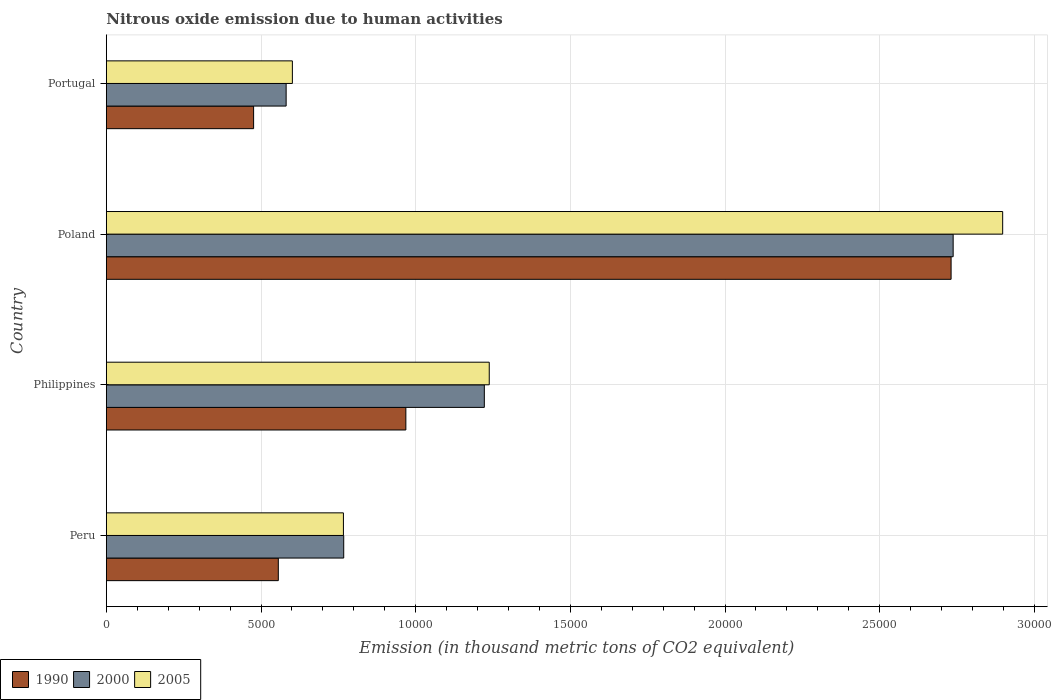Are the number of bars per tick equal to the number of legend labels?
Make the answer very short. Yes. Are the number of bars on each tick of the Y-axis equal?
Your answer should be very brief. Yes. How many bars are there on the 4th tick from the top?
Your response must be concise. 3. How many bars are there on the 4th tick from the bottom?
Keep it short and to the point. 3. In how many cases, is the number of bars for a given country not equal to the number of legend labels?
Ensure brevity in your answer.  0. What is the amount of nitrous oxide emitted in 2005 in Poland?
Give a very brief answer. 2.90e+04. Across all countries, what is the maximum amount of nitrous oxide emitted in 2005?
Your answer should be compact. 2.90e+04. Across all countries, what is the minimum amount of nitrous oxide emitted in 2000?
Offer a terse response. 5812.6. In which country was the amount of nitrous oxide emitted in 2000 minimum?
Give a very brief answer. Portugal. What is the total amount of nitrous oxide emitted in 2000 in the graph?
Provide a short and direct response. 5.31e+04. What is the difference between the amount of nitrous oxide emitted in 2000 in Peru and that in Philippines?
Make the answer very short. -4545.2. What is the difference between the amount of nitrous oxide emitted in 2005 in Peru and the amount of nitrous oxide emitted in 2000 in Portugal?
Give a very brief answer. 1851.6. What is the average amount of nitrous oxide emitted in 2000 per country?
Provide a short and direct response. 1.33e+04. What is the difference between the amount of nitrous oxide emitted in 2005 and amount of nitrous oxide emitted in 2000 in Peru?
Provide a succinct answer. -9.7. What is the ratio of the amount of nitrous oxide emitted in 1990 in Philippines to that in Poland?
Your answer should be compact. 0.35. What is the difference between the highest and the second highest amount of nitrous oxide emitted in 2005?
Provide a succinct answer. 1.66e+04. What is the difference between the highest and the lowest amount of nitrous oxide emitted in 2005?
Keep it short and to the point. 2.30e+04. Is the sum of the amount of nitrous oxide emitted in 2005 in Philippines and Portugal greater than the maximum amount of nitrous oxide emitted in 2000 across all countries?
Your answer should be very brief. No. What does the 1st bar from the bottom in Poland represents?
Give a very brief answer. 1990. How many bars are there?
Offer a very short reply. 12. Are all the bars in the graph horizontal?
Provide a short and direct response. Yes. How many countries are there in the graph?
Give a very brief answer. 4. What is the difference between two consecutive major ticks on the X-axis?
Provide a short and direct response. 5000. Does the graph contain any zero values?
Offer a very short reply. No. How many legend labels are there?
Offer a terse response. 3. What is the title of the graph?
Your answer should be compact. Nitrous oxide emission due to human activities. Does "1982" appear as one of the legend labels in the graph?
Provide a succinct answer. No. What is the label or title of the X-axis?
Keep it short and to the point. Emission (in thousand metric tons of CO2 equivalent). What is the label or title of the Y-axis?
Provide a succinct answer. Country. What is the Emission (in thousand metric tons of CO2 equivalent) of 1990 in Peru?
Make the answer very short. 5559.3. What is the Emission (in thousand metric tons of CO2 equivalent) of 2000 in Peru?
Offer a very short reply. 7673.9. What is the Emission (in thousand metric tons of CO2 equivalent) of 2005 in Peru?
Offer a very short reply. 7664.2. What is the Emission (in thousand metric tons of CO2 equivalent) in 1990 in Philippines?
Give a very brief answer. 9682.8. What is the Emission (in thousand metric tons of CO2 equivalent) of 2000 in Philippines?
Provide a succinct answer. 1.22e+04. What is the Emission (in thousand metric tons of CO2 equivalent) of 2005 in Philippines?
Provide a succinct answer. 1.24e+04. What is the Emission (in thousand metric tons of CO2 equivalent) in 1990 in Poland?
Provide a short and direct response. 2.73e+04. What is the Emission (in thousand metric tons of CO2 equivalent) in 2000 in Poland?
Provide a succinct answer. 2.74e+04. What is the Emission (in thousand metric tons of CO2 equivalent) of 2005 in Poland?
Offer a terse response. 2.90e+04. What is the Emission (in thousand metric tons of CO2 equivalent) of 1990 in Portugal?
Make the answer very short. 4760.8. What is the Emission (in thousand metric tons of CO2 equivalent) in 2000 in Portugal?
Your response must be concise. 5812.6. What is the Emission (in thousand metric tons of CO2 equivalent) of 2005 in Portugal?
Offer a terse response. 6014.2. Across all countries, what is the maximum Emission (in thousand metric tons of CO2 equivalent) of 1990?
Your answer should be compact. 2.73e+04. Across all countries, what is the maximum Emission (in thousand metric tons of CO2 equivalent) in 2000?
Keep it short and to the point. 2.74e+04. Across all countries, what is the maximum Emission (in thousand metric tons of CO2 equivalent) in 2005?
Your answer should be very brief. 2.90e+04. Across all countries, what is the minimum Emission (in thousand metric tons of CO2 equivalent) in 1990?
Make the answer very short. 4760.8. Across all countries, what is the minimum Emission (in thousand metric tons of CO2 equivalent) of 2000?
Your response must be concise. 5812.6. Across all countries, what is the minimum Emission (in thousand metric tons of CO2 equivalent) in 2005?
Offer a very short reply. 6014.2. What is the total Emission (in thousand metric tons of CO2 equivalent) in 1990 in the graph?
Keep it short and to the point. 4.73e+04. What is the total Emission (in thousand metric tons of CO2 equivalent) of 2000 in the graph?
Your answer should be compact. 5.31e+04. What is the total Emission (in thousand metric tons of CO2 equivalent) of 2005 in the graph?
Your answer should be compact. 5.50e+04. What is the difference between the Emission (in thousand metric tons of CO2 equivalent) in 1990 in Peru and that in Philippines?
Your answer should be very brief. -4123.5. What is the difference between the Emission (in thousand metric tons of CO2 equivalent) of 2000 in Peru and that in Philippines?
Make the answer very short. -4545.2. What is the difference between the Emission (in thousand metric tons of CO2 equivalent) of 2005 in Peru and that in Philippines?
Provide a short and direct response. -4713.9. What is the difference between the Emission (in thousand metric tons of CO2 equivalent) of 1990 in Peru and that in Poland?
Keep it short and to the point. -2.17e+04. What is the difference between the Emission (in thousand metric tons of CO2 equivalent) in 2000 in Peru and that in Poland?
Offer a terse response. -1.97e+04. What is the difference between the Emission (in thousand metric tons of CO2 equivalent) of 2005 in Peru and that in Poland?
Keep it short and to the point. -2.13e+04. What is the difference between the Emission (in thousand metric tons of CO2 equivalent) in 1990 in Peru and that in Portugal?
Provide a succinct answer. 798.5. What is the difference between the Emission (in thousand metric tons of CO2 equivalent) of 2000 in Peru and that in Portugal?
Offer a very short reply. 1861.3. What is the difference between the Emission (in thousand metric tons of CO2 equivalent) of 2005 in Peru and that in Portugal?
Your answer should be compact. 1650. What is the difference between the Emission (in thousand metric tons of CO2 equivalent) in 1990 in Philippines and that in Poland?
Provide a short and direct response. -1.76e+04. What is the difference between the Emission (in thousand metric tons of CO2 equivalent) in 2000 in Philippines and that in Poland?
Your answer should be compact. -1.52e+04. What is the difference between the Emission (in thousand metric tons of CO2 equivalent) in 2005 in Philippines and that in Poland?
Provide a short and direct response. -1.66e+04. What is the difference between the Emission (in thousand metric tons of CO2 equivalent) of 1990 in Philippines and that in Portugal?
Offer a terse response. 4922. What is the difference between the Emission (in thousand metric tons of CO2 equivalent) of 2000 in Philippines and that in Portugal?
Offer a very short reply. 6406.5. What is the difference between the Emission (in thousand metric tons of CO2 equivalent) of 2005 in Philippines and that in Portugal?
Offer a terse response. 6363.9. What is the difference between the Emission (in thousand metric tons of CO2 equivalent) in 1990 in Poland and that in Portugal?
Your answer should be compact. 2.25e+04. What is the difference between the Emission (in thousand metric tons of CO2 equivalent) in 2000 in Poland and that in Portugal?
Provide a short and direct response. 2.16e+04. What is the difference between the Emission (in thousand metric tons of CO2 equivalent) of 2005 in Poland and that in Portugal?
Ensure brevity in your answer.  2.30e+04. What is the difference between the Emission (in thousand metric tons of CO2 equivalent) of 1990 in Peru and the Emission (in thousand metric tons of CO2 equivalent) of 2000 in Philippines?
Ensure brevity in your answer.  -6659.8. What is the difference between the Emission (in thousand metric tons of CO2 equivalent) of 1990 in Peru and the Emission (in thousand metric tons of CO2 equivalent) of 2005 in Philippines?
Provide a short and direct response. -6818.8. What is the difference between the Emission (in thousand metric tons of CO2 equivalent) of 2000 in Peru and the Emission (in thousand metric tons of CO2 equivalent) of 2005 in Philippines?
Offer a very short reply. -4704.2. What is the difference between the Emission (in thousand metric tons of CO2 equivalent) of 1990 in Peru and the Emission (in thousand metric tons of CO2 equivalent) of 2000 in Poland?
Provide a succinct answer. -2.18e+04. What is the difference between the Emission (in thousand metric tons of CO2 equivalent) of 1990 in Peru and the Emission (in thousand metric tons of CO2 equivalent) of 2005 in Poland?
Keep it short and to the point. -2.34e+04. What is the difference between the Emission (in thousand metric tons of CO2 equivalent) of 2000 in Peru and the Emission (in thousand metric tons of CO2 equivalent) of 2005 in Poland?
Ensure brevity in your answer.  -2.13e+04. What is the difference between the Emission (in thousand metric tons of CO2 equivalent) of 1990 in Peru and the Emission (in thousand metric tons of CO2 equivalent) of 2000 in Portugal?
Make the answer very short. -253.3. What is the difference between the Emission (in thousand metric tons of CO2 equivalent) of 1990 in Peru and the Emission (in thousand metric tons of CO2 equivalent) of 2005 in Portugal?
Your answer should be compact. -454.9. What is the difference between the Emission (in thousand metric tons of CO2 equivalent) in 2000 in Peru and the Emission (in thousand metric tons of CO2 equivalent) in 2005 in Portugal?
Offer a terse response. 1659.7. What is the difference between the Emission (in thousand metric tons of CO2 equivalent) of 1990 in Philippines and the Emission (in thousand metric tons of CO2 equivalent) of 2000 in Poland?
Give a very brief answer. -1.77e+04. What is the difference between the Emission (in thousand metric tons of CO2 equivalent) of 1990 in Philippines and the Emission (in thousand metric tons of CO2 equivalent) of 2005 in Poland?
Offer a very short reply. -1.93e+04. What is the difference between the Emission (in thousand metric tons of CO2 equivalent) of 2000 in Philippines and the Emission (in thousand metric tons of CO2 equivalent) of 2005 in Poland?
Ensure brevity in your answer.  -1.68e+04. What is the difference between the Emission (in thousand metric tons of CO2 equivalent) of 1990 in Philippines and the Emission (in thousand metric tons of CO2 equivalent) of 2000 in Portugal?
Keep it short and to the point. 3870.2. What is the difference between the Emission (in thousand metric tons of CO2 equivalent) in 1990 in Philippines and the Emission (in thousand metric tons of CO2 equivalent) in 2005 in Portugal?
Your answer should be very brief. 3668.6. What is the difference between the Emission (in thousand metric tons of CO2 equivalent) in 2000 in Philippines and the Emission (in thousand metric tons of CO2 equivalent) in 2005 in Portugal?
Offer a terse response. 6204.9. What is the difference between the Emission (in thousand metric tons of CO2 equivalent) in 1990 in Poland and the Emission (in thousand metric tons of CO2 equivalent) in 2000 in Portugal?
Your answer should be very brief. 2.15e+04. What is the difference between the Emission (in thousand metric tons of CO2 equivalent) in 1990 in Poland and the Emission (in thousand metric tons of CO2 equivalent) in 2005 in Portugal?
Provide a succinct answer. 2.13e+04. What is the difference between the Emission (in thousand metric tons of CO2 equivalent) in 2000 in Poland and the Emission (in thousand metric tons of CO2 equivalent) in 2005 in Portugal?
Your answer should be compact. 2.14e+04. What is the average Emission (in thousand metric tons of CO2 equivalent) of 1990 per country?
Your answer should be very brief. 1.18e+04. What is the average Emission (in thousand metric tons of CO2 equivalent) of 2000 per country?
Ensure brevity in your answer.  1.33e+04. What is the average Emission (in thousand metric tons of CO2 equivalent) of 2005 per country?
Keep it short and to the point. 1.38e+04. What is the difference between the Emission (in thousand metric tons of CO2 equivalent) in 1990 and Emission (in thousand metric tons of CO2 equivalent) in 2000 in Peru?
Offer a very short reply. -2114.6. What is the difference between the Emission (in thousand metric tons of CO2 equivalent) in 1990 and Emission (in thousand metric tons of CO2 equivalent) in 2005 in Peru?
Offer a very short reply. -2104.9. What is the difference between the Emission (in thousand metric tons of CO2 equivalent) in 1990 and Emission (in thousand metric tons of CO2 equivalent) in 2000 in Philippines?
Keep it short and to the point. -2536.3. What is the difference between the Emission (in thousand metric tons of CO2 equivalent) of 1990 and Emission (in thousand metric tons of CO2 equivalent) of 2005 in Philippines?
Provide a succinct answer. -2695.3. What is the difference between the Emission (in thousand metric tons of CO2 equivalent) in 2000 and Emission (in thousand metric tons of CO2 equivalent) in 2005 in Philippines?
Ensure brevity in your answer.  -159. What is the difference between the Emission (in thousand metric tons of CO2 equivalent) of 1990 and Emission (in thousand metric tons of CO2 equivalent) of 2000 in Poland?
Your response must be concise. -66.8. What is the difference between the Emission (in thousand metric tons of CO2 equivalent) in 1990 and Emission (in thousand metric tons of CO2 equivalent) in 2005 in Poland?
Ensure brevity in your answer.  -1667.4. What is the difference between the Emission (in thousand metric tons of CO2 equivalent) in 2000 and Emission (in thousand metric tons of CO2 equivalent) in 2005 in Poland?
Give a very brief answer. -1600.6. What is the difference between the Emission (in thousand metric tons of CO2 equivalent) of 1990 and Emission (in thousand metric tons of CO2 equivalent) of 2000 in Portugal?
Ensure brevity in your answer.  -1051.8. What is the difference between the Emission (in thousand metric tons of CO2 equivalent) of 1990 and Emission (in thousand metric tons of CO2 equivalent) of 2005 in Portugal?
Offer a terse response. -1253.4. What is the difference between the Emission (in thousand metric tons of CO2 equivalent) in 2000 and Emission (in thousand metric tons of CO2 equivalent) in 2005 in Portugal?
Make the answer very short. -201.6. What is the ratio of the Emission (in thousand metric tons of CO2 equivalent) of 1990 in Peru to that in Philippines?
Offer a terse response. 0.57. What is the ratio of the Emission (in thousand metric tons of CO2 equivalent) in 2000 in Peru to that in Philippines?
Offer a very short reply. 0.63. What is the ratio of the Emission (in thousand metric tons of CO2 equivalent) of 2005 in Peru to that in Philippines?
Make the answer very short. 0.62. What is the ratio of the Emission (in thousand metric tons of CO2 equivalent) in 1990 in Peru to that in Poland?
Make the answer very short. 0.2. What is the ratio of the Emission (in thousand metric tons of CO2 equivalent) of 2000 in Peru to that in Poland?
Give a very brief answer. 0.28. What is the ratio of the Emission (in thousand metric tons of CO2 equivalent) of 2005 in Peru to that in Poland?
Your answer should be very brief. 0.26. What is the ratio of the Emission (in thousand metric tons of CO2 equivalent) of 1990 in Peru to that in Portugal?
Provide a short and direct response. 1.17. What is the ratio of the Emission (in thousand metric tons of CO2 equivalent) of 2000 in Peru to that in Portugal?
Your response must be concise. 1.32. What is the ratio of the Emission (in thousand metric tons of CO2 equivalent) in 2005 in Peru to that in Portugal?
Your response must be concise. 1.27. What is the ratio of the Emission (in thousand metric tons of CO2 equivalent) of 1990 in Philippines to that in Poland?
Your answer should be compact. 0.35. What is the ratio of the Emission (in thousand metric tons of CO2 equivalent) in 2000 in Philippines to that in Poland?
Keep it short and to the point. 0.45. What is the ratio of the Emission (in thousand metric tons of CO2 equivalent) in 2005 in Philippines to that in Poland?
Your response must be concise. 0.43. What is the ratio of the Emission (in thousand metric tons of CO2 equivalent) in 1990 in Philippines to that in Portugal?
Ensure brevity in your answer.  2.03. What is the ratio of the Emission (in thousand metric tons of CO2 equivalent) of 2000 in Philippines to that in Portugal?
Keep it short and to the point. 2.1. What is the ratio of the Emission (in thousand metric tons of CO2 equivalent) in 2005 in Philippines to that in Portugal?
Your answer should be very brief. 2.06. What is the ratio of the Emission (in thousand metric tons of CO2 equivalent) of 1990 in Poland to that in Portugal?
Offer a very short reply. 5.74. What is the ratio of the Emission (in thousand metric tons of CO2 equivalent) in 2000 in Poland to that in Portugal?
Your answer should be very brief. 4.71. What is the ratio of the Emission (in thousand metric tons of CO2 equivalent) of 2005 in Poland to that in Portugal?
Offer a very short reply. 4.82. What is the difference between the highest and the second highest Emission (in thousand metric tons of CO2 equivalent) of 1990?
Give a very brief answer. 1.76e+04. What is the difference between the highest and the second highest Emission (in thousand metric tons of CO2 equivalent) in 2000?
Provide a succinct answer. 1.52e+04. What is the difference between the highest and the second highest Emission (in thousand metric tons of CO2 equivalent) of 2005?
Make the answer very short. 1.66e+04. What is the difference between the highest and the lowest Emission (in thousand metric tons of CO2 equivalent) of 1990?
Make the answer very short. 2.25e+04. What is the difference between the highest and the lowest Emission (in thousand metric tons of CO2 equivalent) of 2000?
Provide a succinct answer. 2.16e+04. What is the difference between the highest and the lowest Emission (in thousand metric tons of CO2 equivalent) in 2005?
Your response must be concise. 2.30e+04. 